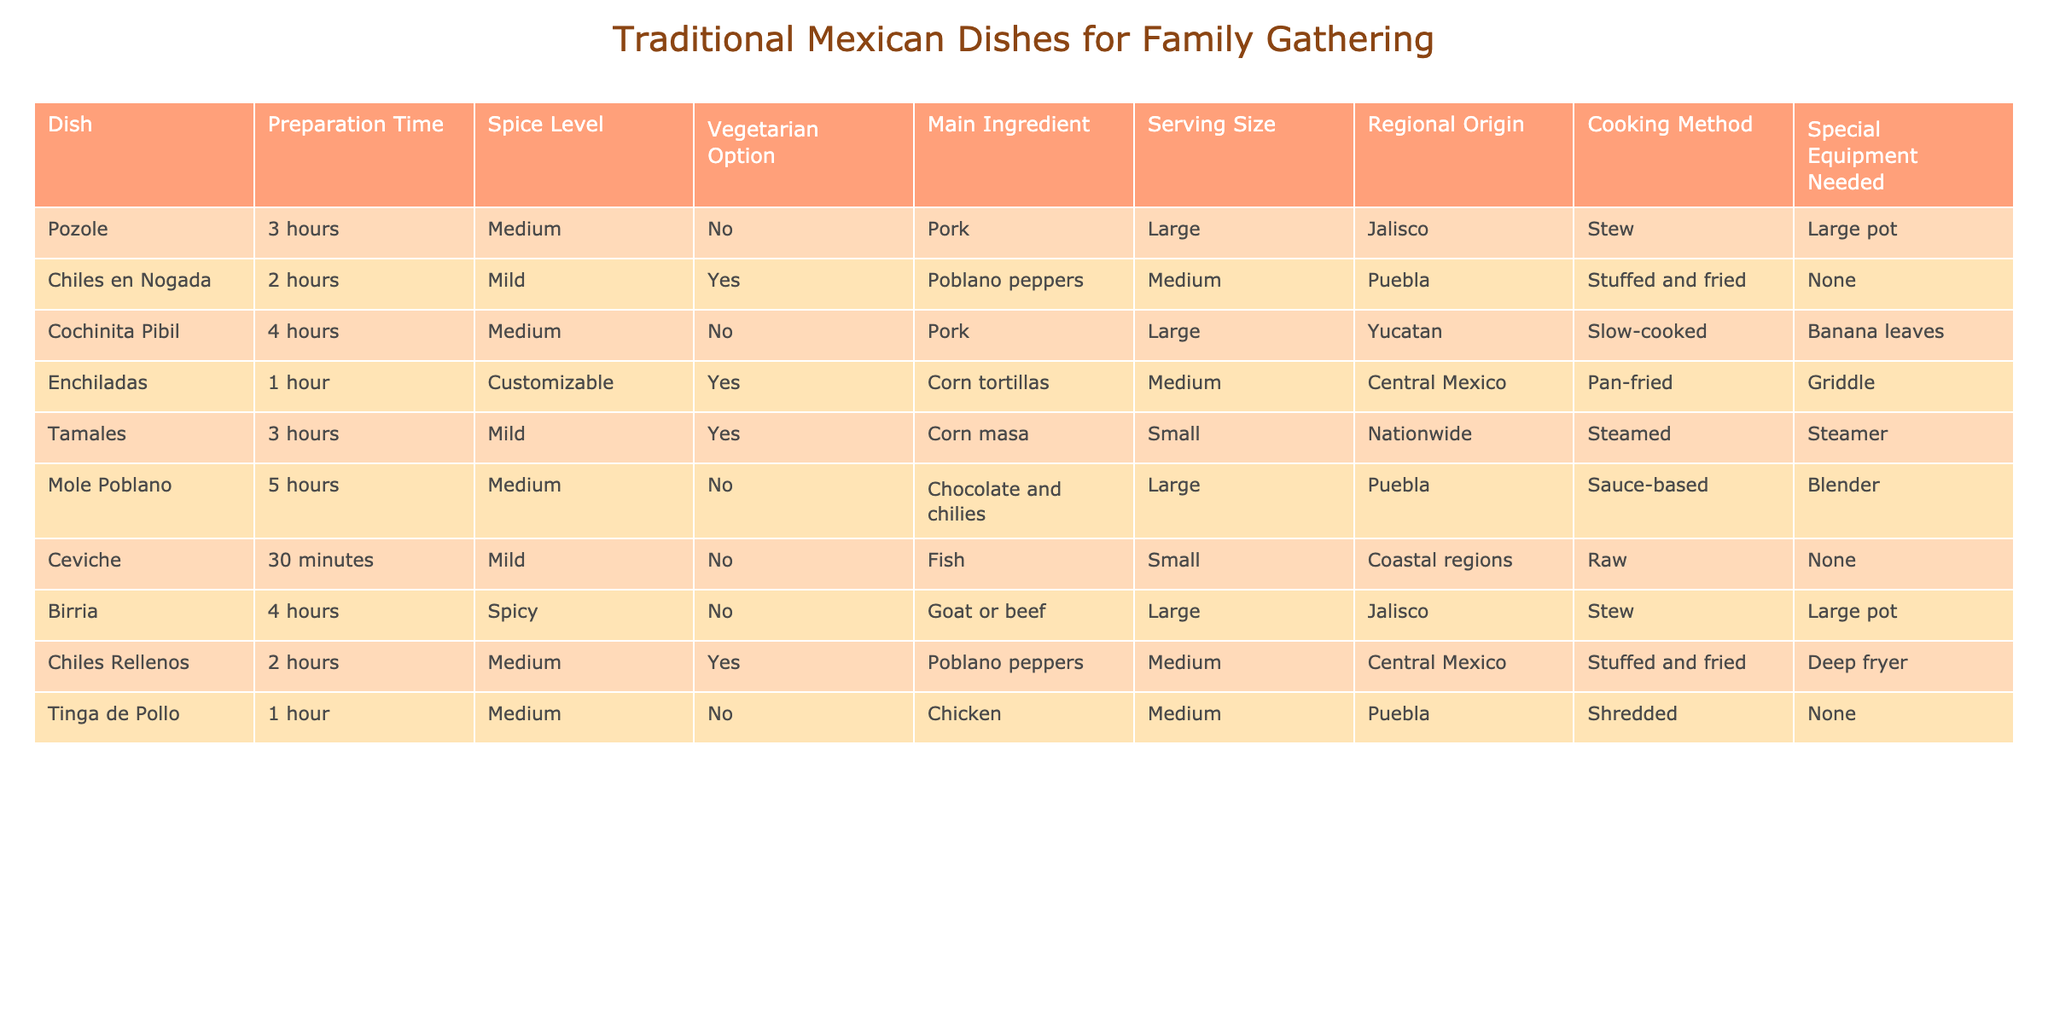What is the preparation time for Chiles en Nogada? The table lists the preparation time for Chiles en Nogada as 2 hours.
Answer: 2 hours How many dishes have a ‘Medium’ spice level? By counting the dishes that have a 'Medium' spice level, we find Pozole, Cochinita Pibil, Enchiladas, Chiles Rellenos, and Tinga de Pollo—totaling 5 dishes.
Answer: 5 Is Ceviche a vegetarian option? The table specifies that Ceviche is not a vegetarian option, as the main ingredient is fish.
Answer: No Which dish has the longest preparation time, and what is it? By reviewing the preparation times, Cochinita Pibil has the longest preparation time of 4 hours.
Answer: Cochinita Pibil What is the average preparation time for vegetarian dishes? The vegetarian dishes are Chiles en Nogada, Enchiladas, Tamales, and Chiles Rellenos. Their preparation times are 2 hours, 1 hour, 3 hours, and 2 hours respectively. To find the average: (2 + 1 + 3 + 2) / 4 = 8 / 4 = 2 hours.
Answer: 2 hours Are there any dishes originating from Nayarit? Upon checking the regional origins of all the dishes, none of them list Nayarit as their origin.
Answer: No Which dish uses the special equipment "Steamer"? The table indicates that Tamales requires a Steamer as its special equipment.
Answer: Tamales What is the serving size for Mole Poblano and is it large or small? The serving size for Mole Poblano is listed as Large, meaning it is suitable for serving many people.
Answer: Large 